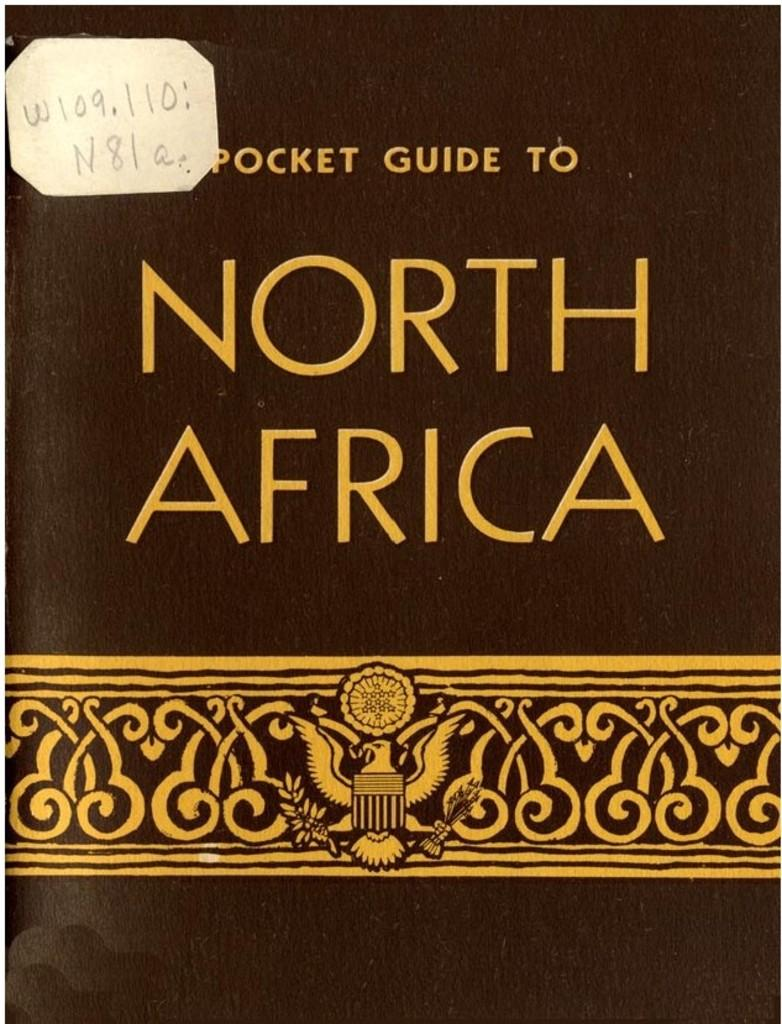What is the main subject of the image? The main subject of the image is the cover page of a book. Are there any fairies visible on the cover page of the book in the image? There is no indication of fairies on the cover page of the book in the image. Is there a parent depicted on the cover page of the book in the image? There is no indication of a parent depicted on the cover page of the book in the image. Can you see any horns on the cover page of the book in the image? There is no indication of horns on the cover page of the book in the image. 